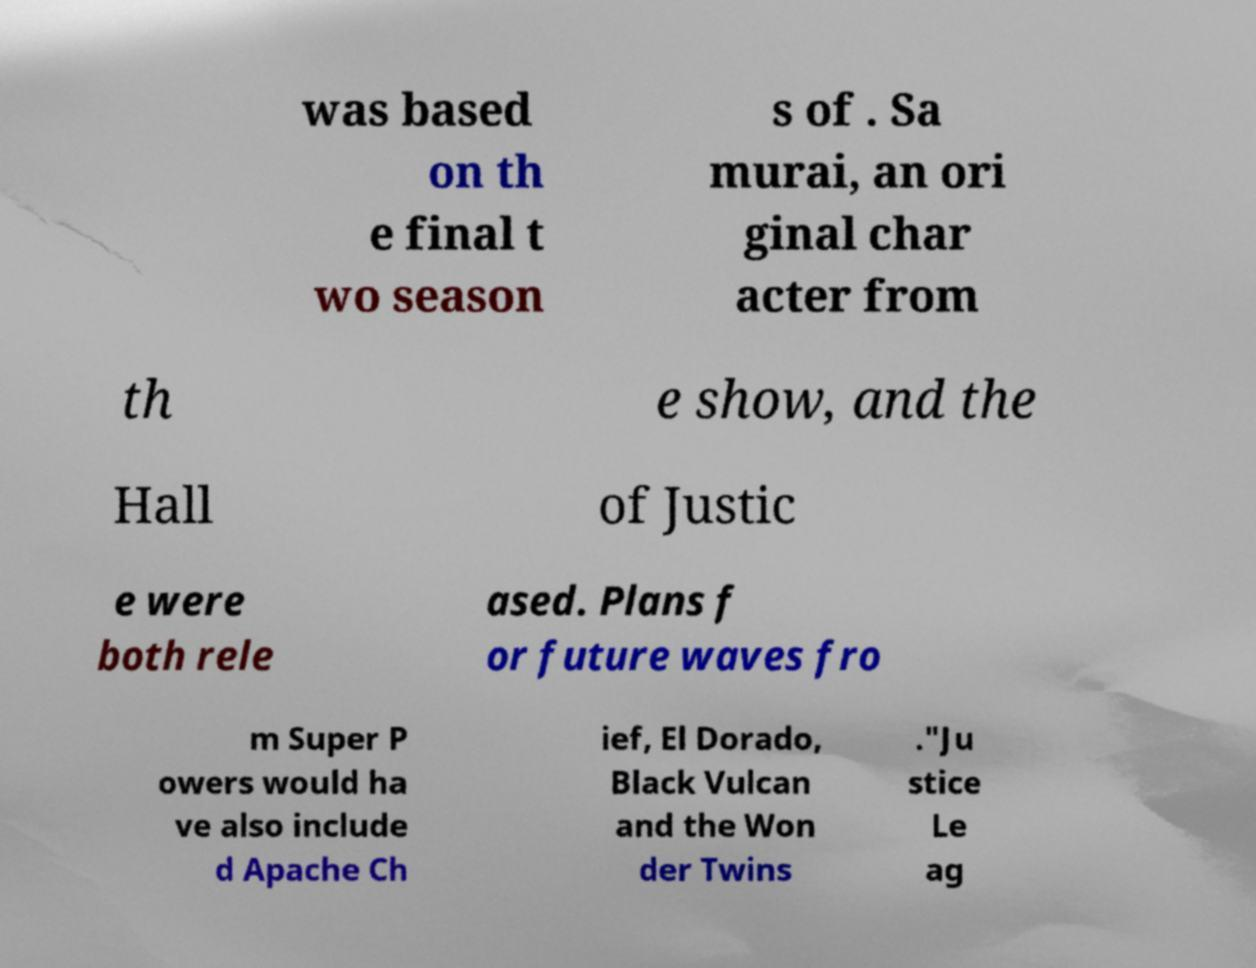Please read and relay the text visible in this image. What does it say? was based on th e final t wo season s of . Sa murai, an ori ginal char acter from th e show, and the Hall of Justic e were both rele ased. Plans f or future waves fro m Super P owers would ha ve also include d Apache Ch ief, El Dorado, Black Vulcan and the Won der Twins ."Ju stice Le ag 